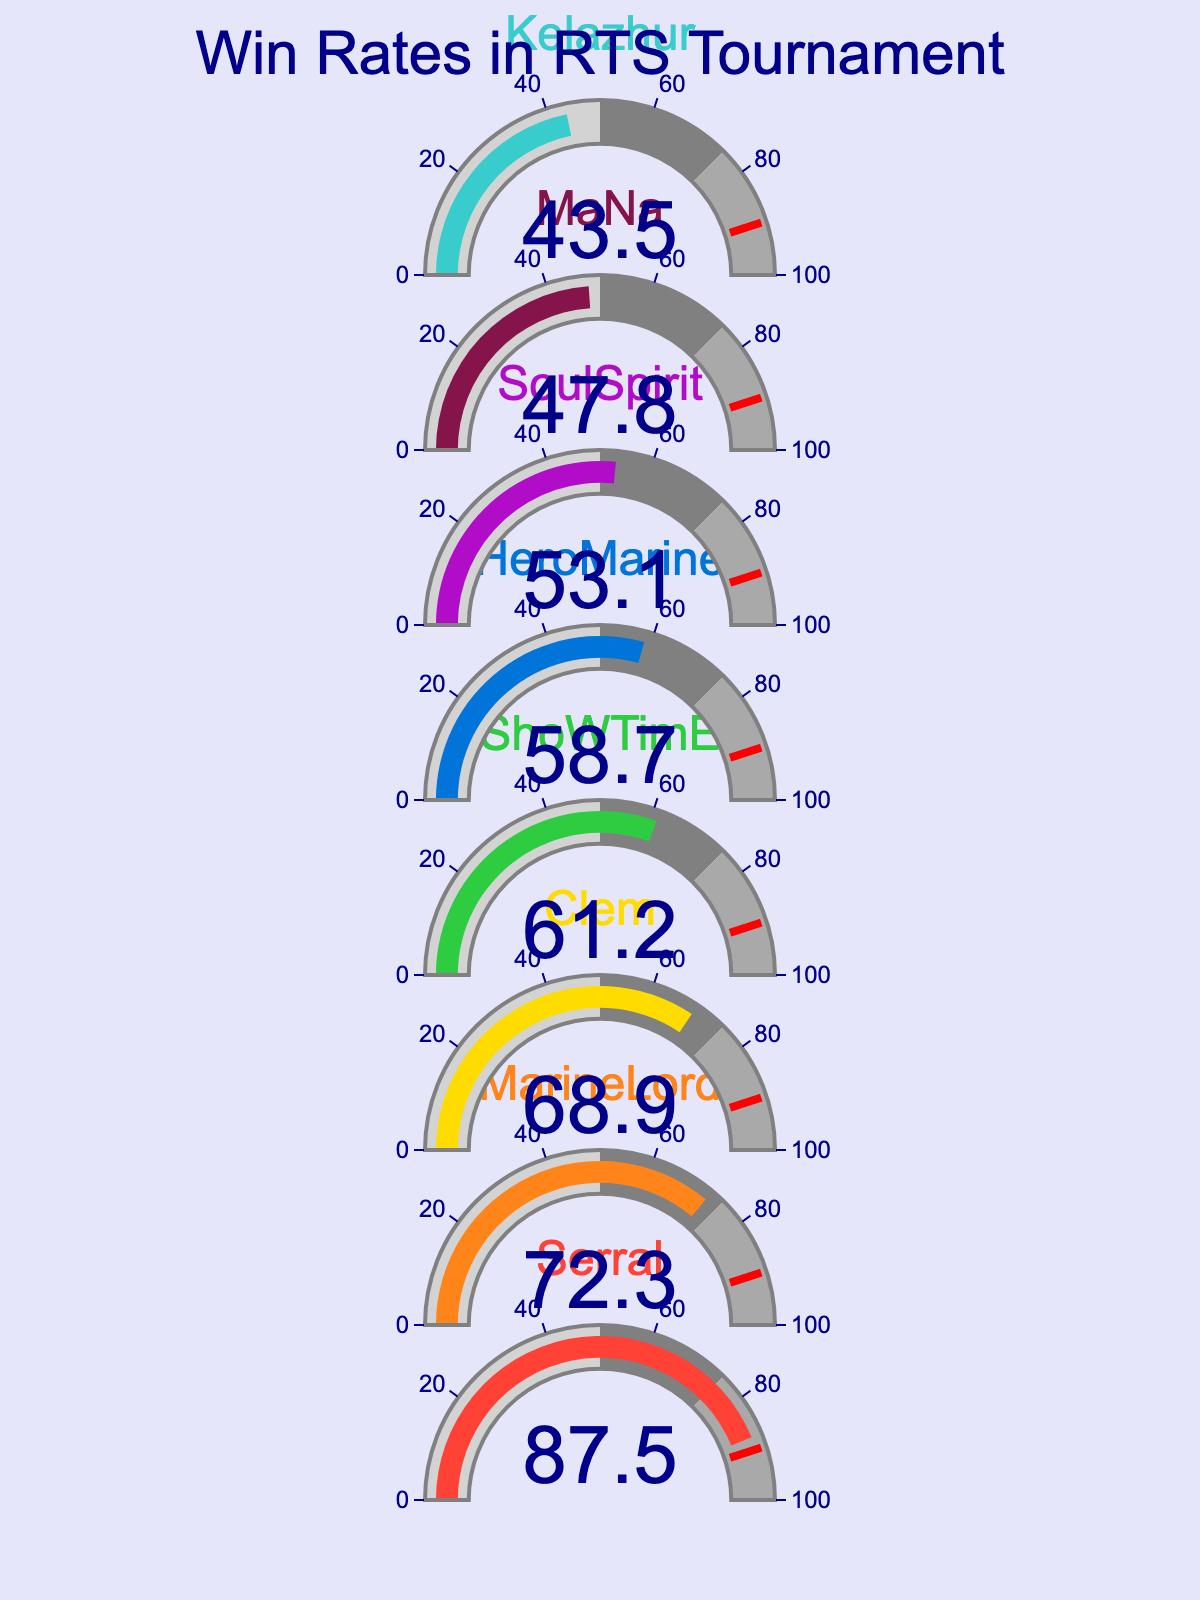What is the win rate of Serral? Based on the gauge chart, find the number displayed in the gauge labeled "Serral".
Answer: 87.5 What is the title of the figure? Look at the top part of the figure where the title is generally placed.
Answer: Win Rates in RTS Tournament How many players have a win rate above 70%? Count the number of players in the gauges that show a win rate above 70%.
Answer: 2 Who has the lowest win rate in the tournament? Check the gauges for the player with the smallest number displayed.
Answer: Kelazhur What is the approximate difference between Serral's and MarineLord's win rates? Subtract MarineLord's win rate from Serral's win rate: 87.5 - 72.3.
Answer: 15.2 What is the sum of win rates for HeroMarine and SoulSpirit? Add the win rates of HeroMarine and SoulSpirit: 58.7 + 53.1.
Answer: 111.8 What is the average win rate of the players? Add all the win rates and divide by the number of players: (87.5 + 72.3 + 68.9 + 61.2 + 58.7 + 53.1 + 47.8 + 43.5) / 8.
Answer: 61.38 Compare the win rate of Clem and ShoWTimE. Which one is higher? Look at the gauges for Clem and ShoWTimE. Identify which gauge has the higher number.
Answer: Clem How many players have win rates in the range of 50% to 75%? Count the number of gauges where the win rate is between 50 and 75.
Answer: 4 What is the difference between the highest and lowest win rates? Subtract the lowest win rate (43.5) from the highest win rate (87.5).
Answer: 44 